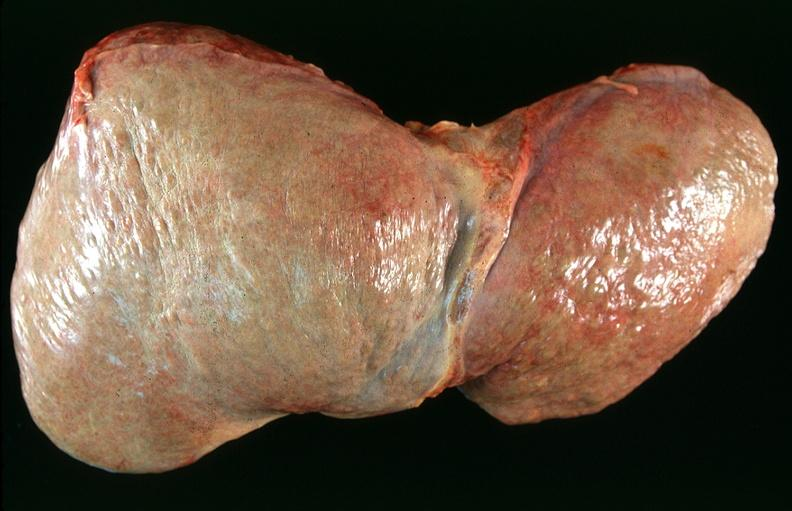what is present?
Answer the question using a single word or phrase. Hepatobiliary 